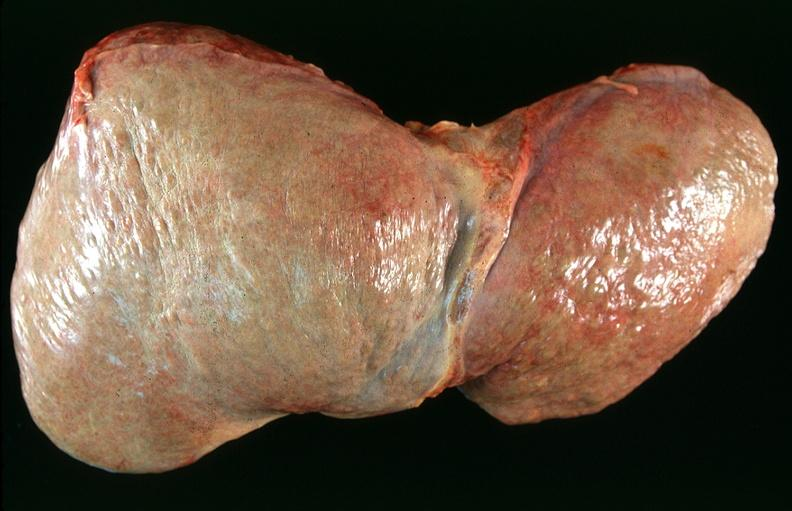what is present?
Answer the question using a single word or phrase. Hepatobiliary 